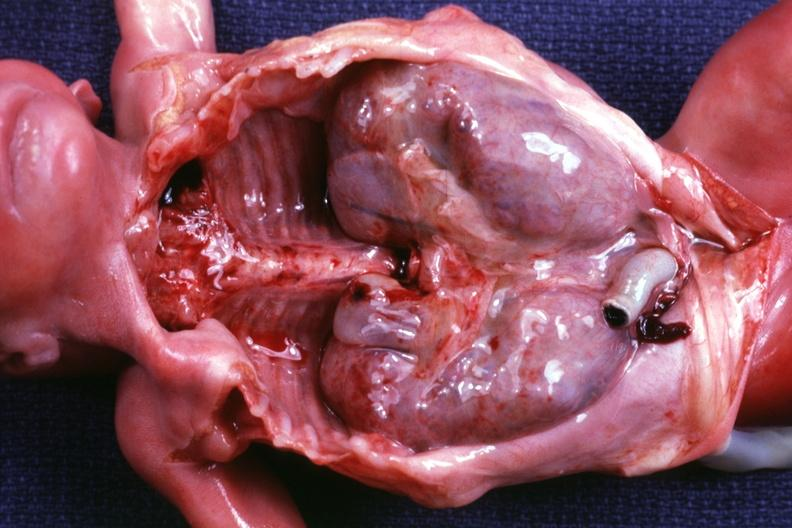what is present?
Answer the question using a single word or phrase. Polycystic disease infant 